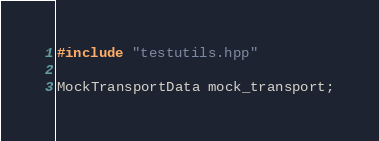Convert code to text. <code><loc_0><loc_0><loc_500><loc_500><_C++_>#include "testutils.hpp"

MockTransportData mock_transport;
</code> 